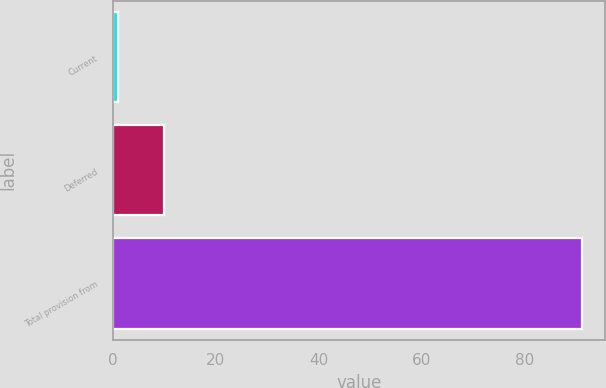Convert chart. <chart><loc_0><loc_0><loc_500><loc_500><bar_chart><fcel>Current<fcel>Deferred<fcel>Total provision from<nl><fcel>1<fcel>10<fcel>91<nl></chart> 